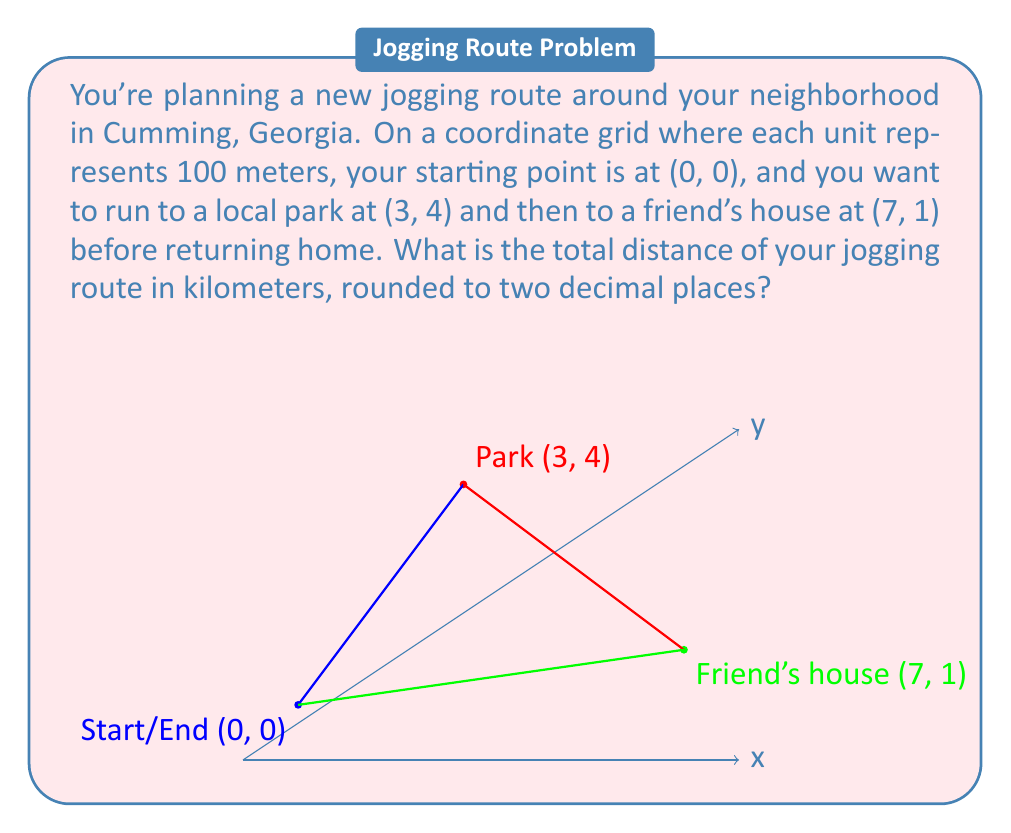Teach me how to tackle this problem. Let's solve this problem step by step using the Pythagorean theorem and distance formula on a coordinate plane:

1) First, let's calculate the distance from the starting point to the park:
   $d_1 = \sqrt{(3-0)^2 + (4-0)^2} = \sqrt{9 + 16} = \sqrt{25} = 5$ units

2) Next, the distance from the park to the friend's house:
   $d_2 = \sqrt{(7-3)^2 + (1-4)^2} = \sqrt{16 + 9} = \sqrt{25} = 5$ units

3) Finally, the distance from the friend's house back to the starting point:
   $d_3 = \sqrt{(0-7)^2 + (0-1)^2} = \sqrt{49 + 1} = \sqrt{50} = 5\sqrt{2}$ units

4) The total distance in units is:
   $d_{total} = d_1 + d_2 + d_3 = 5 + 5 + 5\sqrt{2} = 10 + 5\sqrt{2}$ units

5) Convert units to kilometers:
   Each unit represents 100 meters, so we multiply by 0.1 to get kilometers:
   $d_{km} = (10 + 5\sqrt{2}) * 0.1 = 1 + 0.5\sqrt{2}$ km

6) Calculate the value of $0.5\sqrt{2}$:
   $0.5\sqrt{2} \approx 0.7071$

7) Add this to 1 km:
   $1 + 0.7071 = 1.7071$ km

8) Rounding to two decimal places:
   $1.71$ km

Therefore, the total distance of the jogging route is approximately 1.71 km.
Answer: 1.71 km 